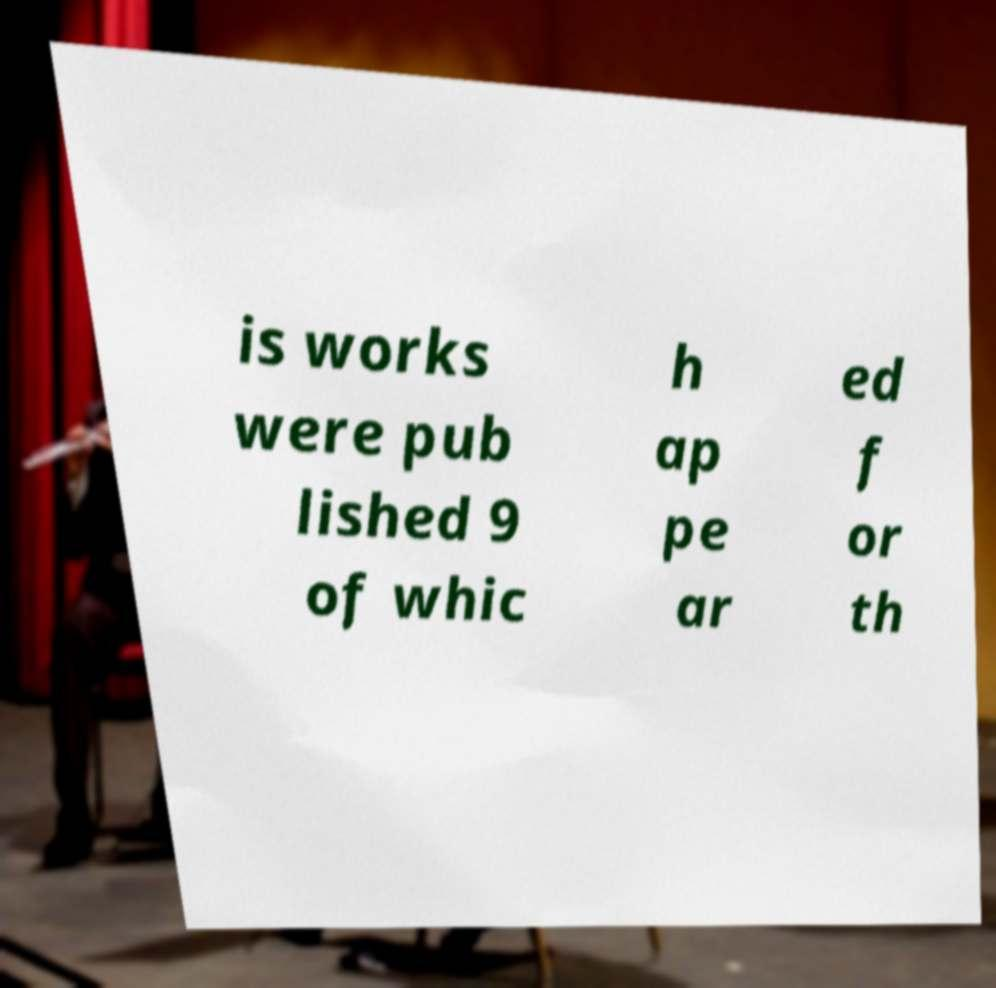For documentation purposes, I need the text within this image transcribed. Could you provide that? is works were pub lished 9 of whic h ap pe ar ed f or th 